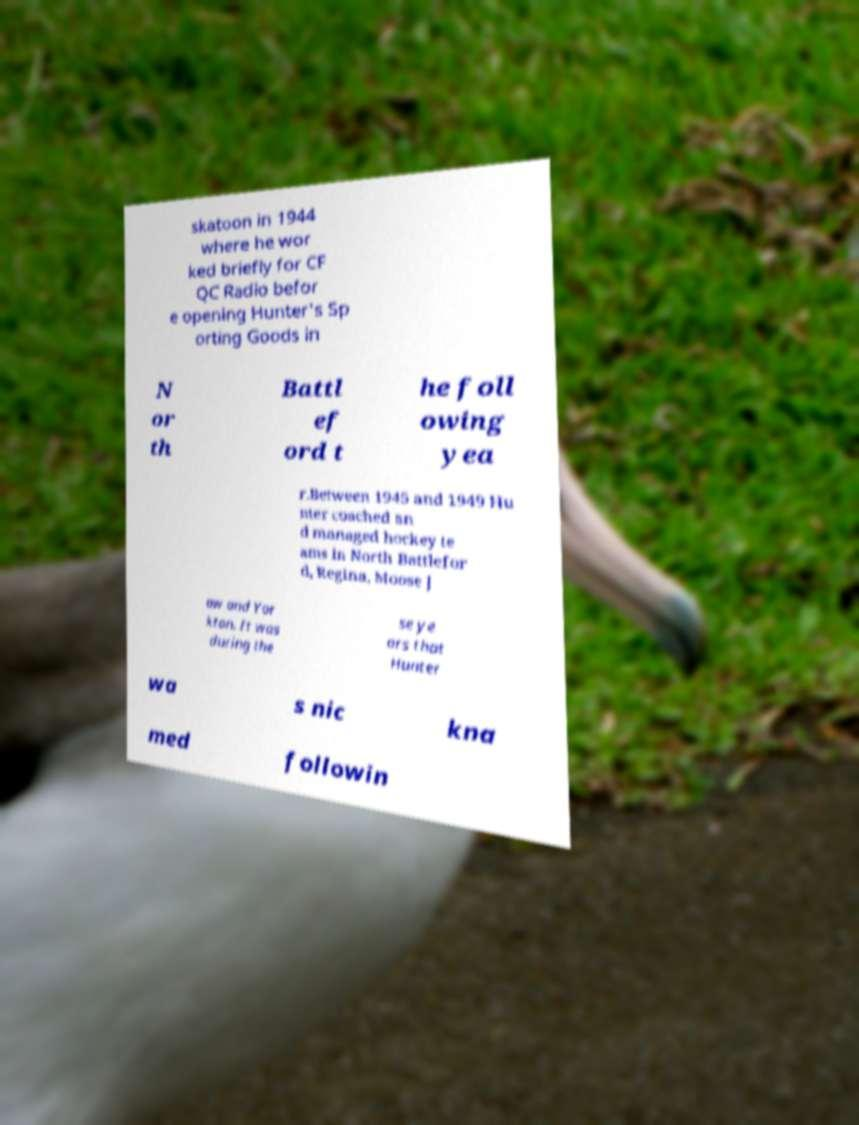Please identify and transcribe the text found in this image. skatoon in 1944 where he wor ked briefly for CF QC Radio befor e opening Hunter's Sp orting Goods in N or th Battl ef ord t he foll owing yea r.Between 1945 and 1949 Hu nter coached an d managed hockey te ams in North Battlefor d, Regina, Moose J aw and Yor kton. It was during the se ye ars that Hunter wa s nic kna med followin 